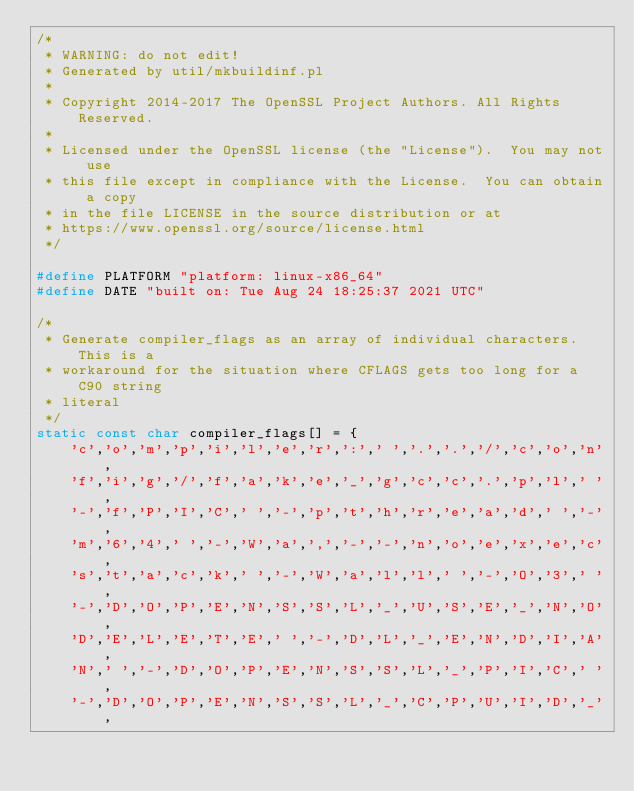<code> <loc_0><loc_0><loc_500><loc_500><_C_>/*
 * WARNING: do not edit!
 * Generated by util/mkbuildinf.pl
 *
 * Copyright 2014-2017 The OpenSSL Project Authors. All Rights Reserved.
 *
 * Licensed under the OpenSSL license (the "License").  You may not use
 * this file except in compliance with the License.  You can obtain a copy
 * in the file LICENSE in the source distribution or at
 * https://www.openssl.org/source/license.html
 */

#define PLATFORM "platform: linux-x86_64"
#define DATE "built on: Tue Aug 24 18:25:37 2021 UTC"

/*
 * Generate compiler_flags as an array of individual characters. This is a
 * workaround for the situation where CFLAGS gets too long for a C90 string
 * literal
 */
static const char compiler_flags[] = {
    'c','o','m','p','i','l','e','r',':',' ','.','.','/','c','o','n',
    'f','i','g','/','f','a','k','e','_','g','c','c','.','p','l',' ',
    '-','f','P','I','C',' ','-','p','t','h','r','e','a','d',' ','-',
    'm','6','4',' ','-','W','a',',','-','-','n','o','e','x','e','c',
    's','t','a','c','k',' ','-','W','a','l','l',' ','-','O','3',' ',
    '-','D','O','P','E','N','S','S','L','_','U','S','E','_','N','O',
    'D','E','L','E','T','E',' ','-','D','L','_','E','N','D','I','A',
    'N',' ','-','D','O','P','E','N','S','S','L','_','P','I','C',' ',
    '-','D','O','P','E','N','S','S','L','_','C','P','U','I','D','_',</code> 